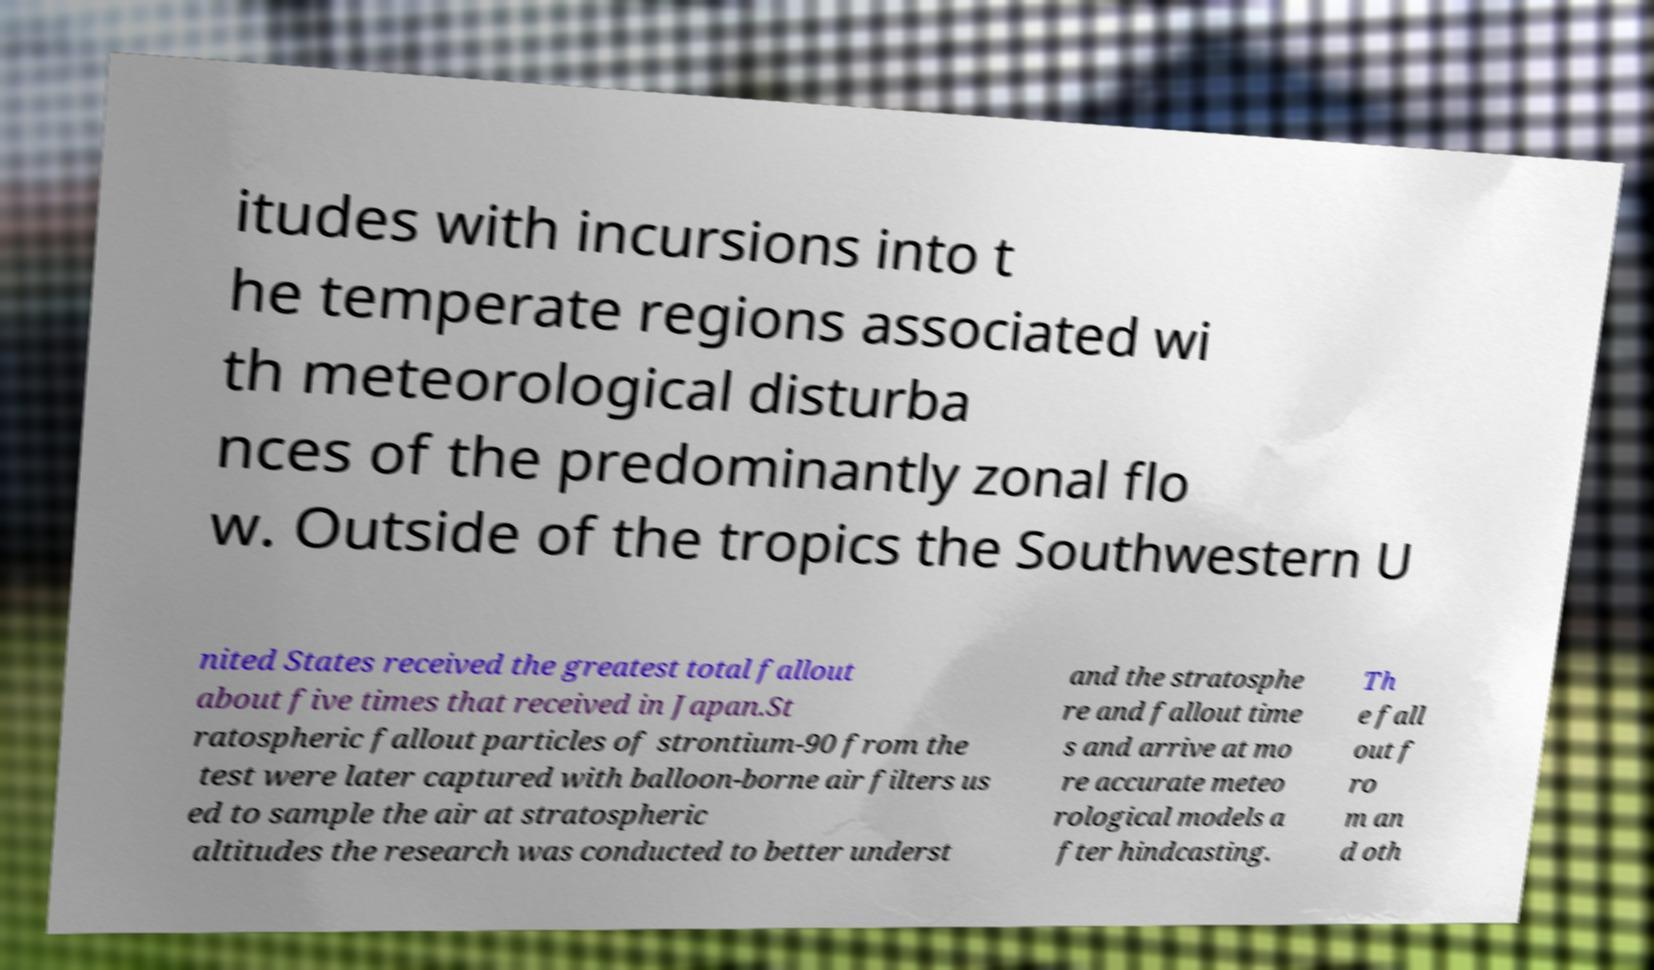Please identify and transcribe the text found in this image. itudes with incursions into t he temperate regions associated wi th meteorological disturba nces of the predominantly zonal flo w. Outside of the tropics the Southwestern U nited States received the greatest total fallout about five times that received in Japan.St ratospheric fallout particles of strontium-90 from the test were later captured with balloon-borne air filters us ed to sample the air at stratospheric altitudes the research was conducted to better underst and the stratosphe re and fallout time s and arrive at mo re accurate meteo rological models a fter hindcasting. Th e fall out f ro m an d oth 